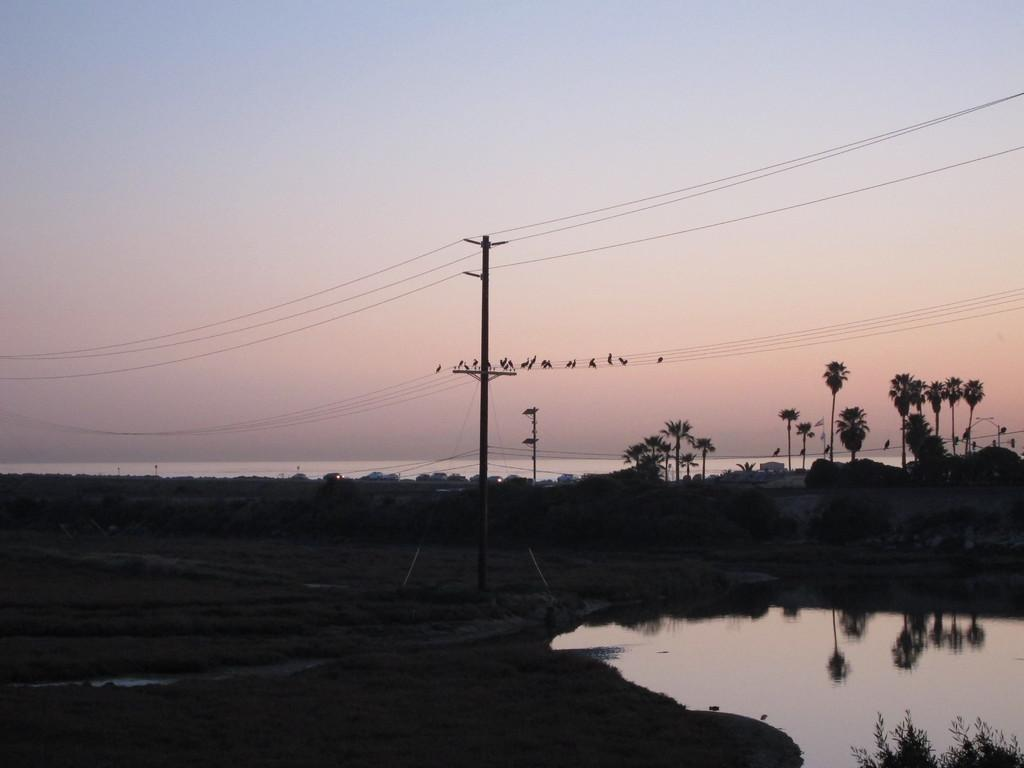What type of vegetation can be seen in the image? There are trees in the image. What else is visible besides the trees? There is water visible in the image, as well as electric poles with cables. What are the birds doing in the image? The birds are on the cables in the image. What can be seen in the background of the image? The sky is visible behind the trees in the image. Can you tell me how many doctors are wearing scarves in the image? There are no doctors or scarves present in the image. What type of wind can be seen blowing the trees in the image? There is no wind visible in the image; the trees are stationary. 